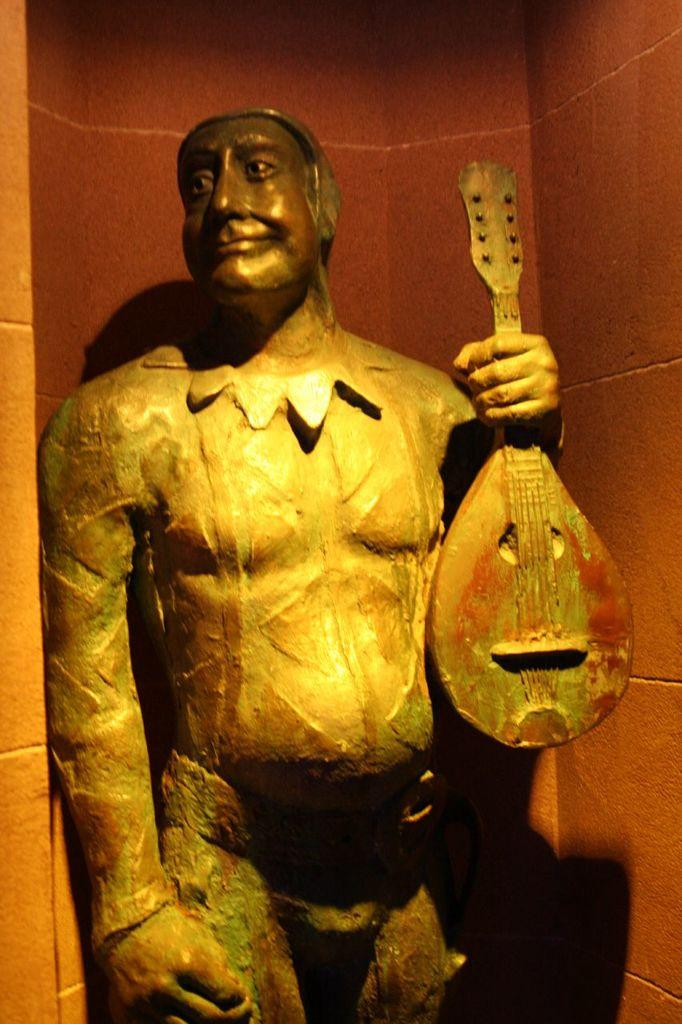What is the main subject of the image? There is an idol of a man in the image. What is the man holding in the image? The man is holding a guitar. What can be seen in the background of the image? There is a wall in the background of the image. What type of glove is the man wearing on his elbow in the image? There is no glove or elbow visible in the image; the man is holding a guitar and there is a wall in the background. 